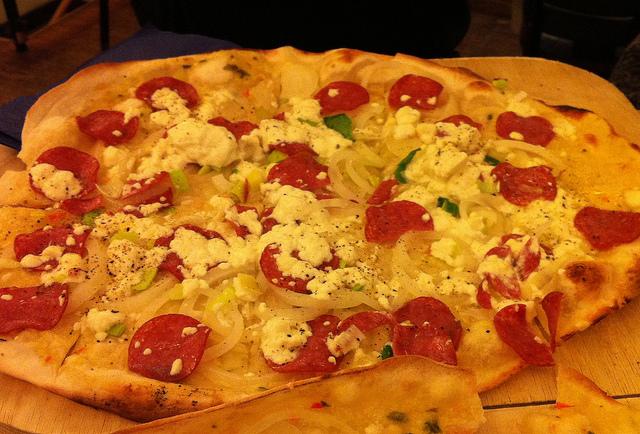Is there meat on this pizza?
Be succinct. Yes. Can you see onions?
Write a very short answer. Yes. What type of cheese is on this pizza?
Keep it brief. Feta. 